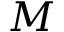Convert formula to latex. <formula><loc_0><loc_0><loc_500><loc_500>M</formula> 